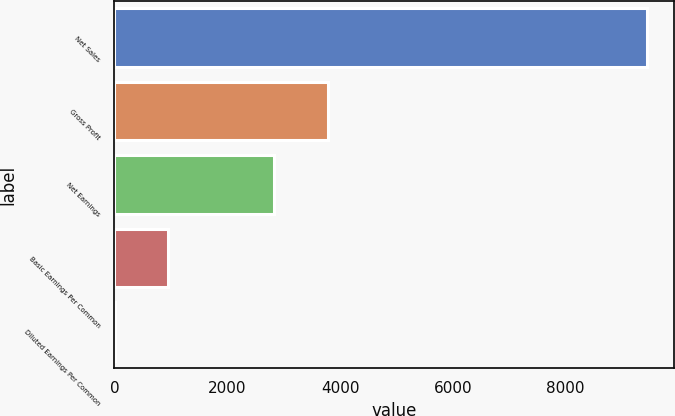Convert chart to OTSL. <chart><loc_0><loc_0><loc_500><loc_500><bar_chart><fcel>Net Sales<fcel>Gross Profit<fcel>Net Earnings<fcel>Basic Earnings Per Common<fcel>Diluted Earnings Per Common<nl><fcel>9447<fcel>3778.97<fcel>2834.3<fcel>944.96<fcel>0.29<nl></chart> 